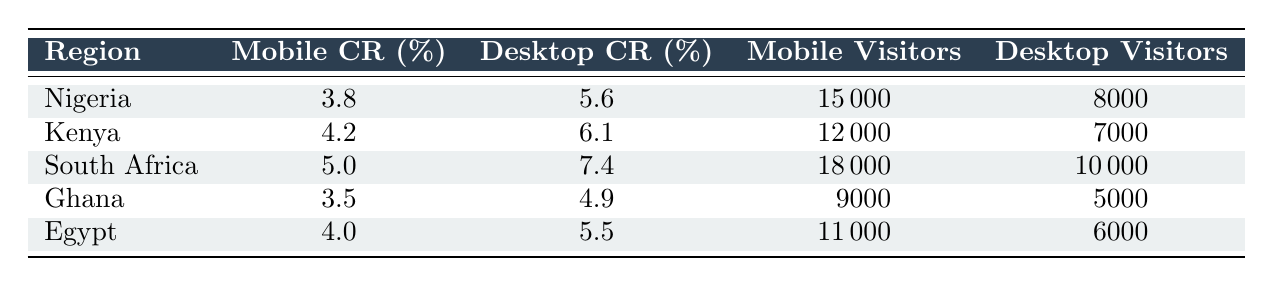What is the highest mobile conversion rate among the regions listed? The table shows mobile conversion rates for each region. Scanning through the mobile conversion rates, South Africa has the highest rate at 5.0%.
Answer: 5.0% Which region has the lowest desktop conversion rate? To find the lowest desktop conversion rate, we look at the values for each region. Ghana has the lowest desktop conversion rate at 4.9%.
Answer: 4.9% What is the total number of mobile visitors across all regions? To find the total number of mobile visitors, we sum the mobile visitors from all regions: 15000 (Nigeria) + 12000 (Kenya) + 18000 (South Africa) + 9000 (Ghana) + 11000 (Egypt) = 75000.
Answer: 75000 Is the mobile conversion rate in Kenya higher than the desktop conversion rate in Ghana? According to the table, Kenya's mobile conversion rate is 4.2%, and Ghana's desktop conversion rate is 4.9%. Comparing these values shows that 4.2% is less than 4.9%, so the statement is false.
Answer: No What is the difference between mobile and desktop conversion rates for Nigeria? For Nigeria, the mobile conversion rate is 3.8% and the desktop conversion rate is 5.6%. The difference is calculated by subtracting the mobile conversion rate from the desktop conversion rate: 5.6% - 3.8% = 1.8%.
Answer: 1.8% 